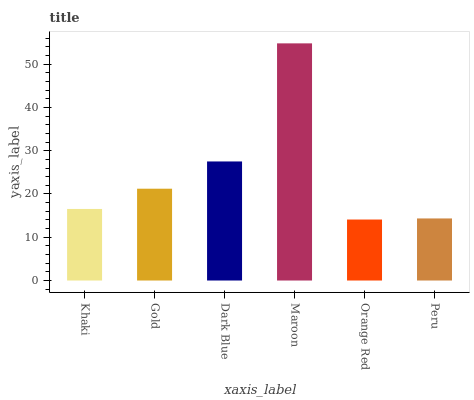Is Orange Red the minimum?
Answer yes or no. Yes. Is Maroon the maximum?
Answer yes or no. Yes. Is Gold the minimum?
Answer yes or no. No. Is Gold the maximum?
Answer yes or no. No. Is Gold greater than Khaki?
Answer yes or no. Yes. Is Khaki less than Gold?
Answer yes or no. Yes. Is Khaki greater than Gold?
Answer yes or no. No. Is Gold less than Khaki?
Answer yes or no. No. Is Gold the high median?
Answer yes or no. Yes. Is Khaki the low median?
Answer yes or no. Yes. Is Maroon the high median?
Answer yes or no. No. Is Maroon the low median?
Answer yes or no. No. 